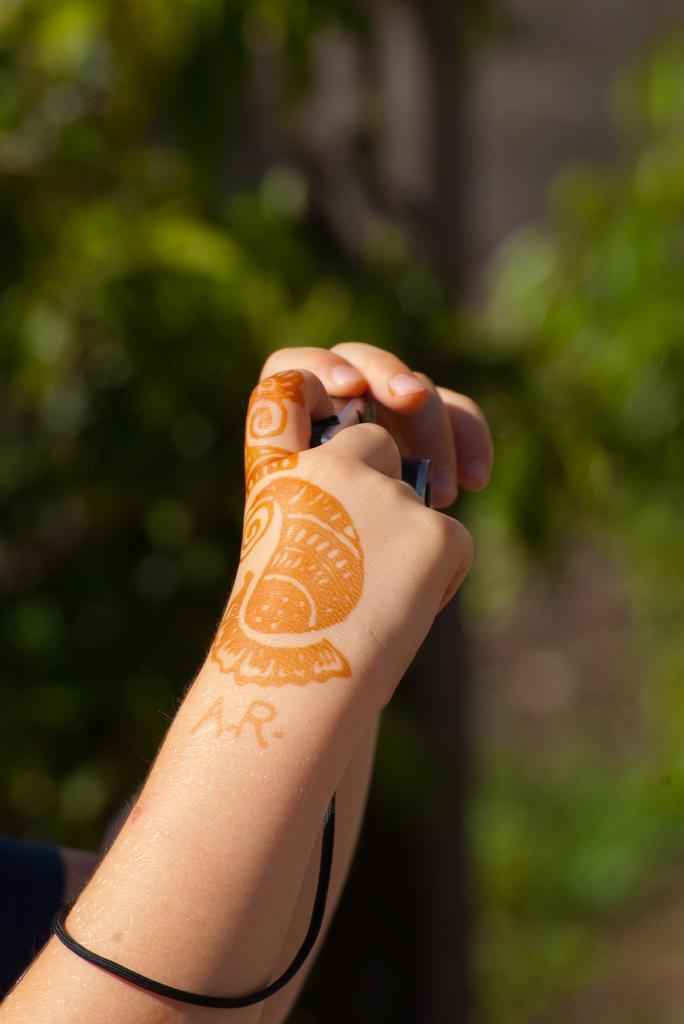Could you give a brief overview of what you see in this image? s we can see in the image in the front there are human hands. In the background there are trees and the background is blurred. 